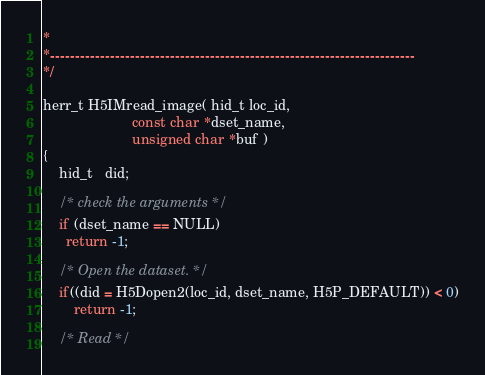Convert code to text. <code><loc_0><loc_0><loc_500><loc_500><_C_>*
*-------------------------------------------------------------------------
*/

herr_t H5IMread_image( hid_t loc_id,
                       const char *dset_name,
                       unsigned char *buf )
{
    hid_t   did;

    /* check the arguments */
    if (dset_name == NULL) 
      return -1;

    /* Open the dataset. */
    if((did = H5Dopen2(loc_id, dset_name, H5P_DEFAULT)) < 0)
        return -1;

    /* Read */</code> 